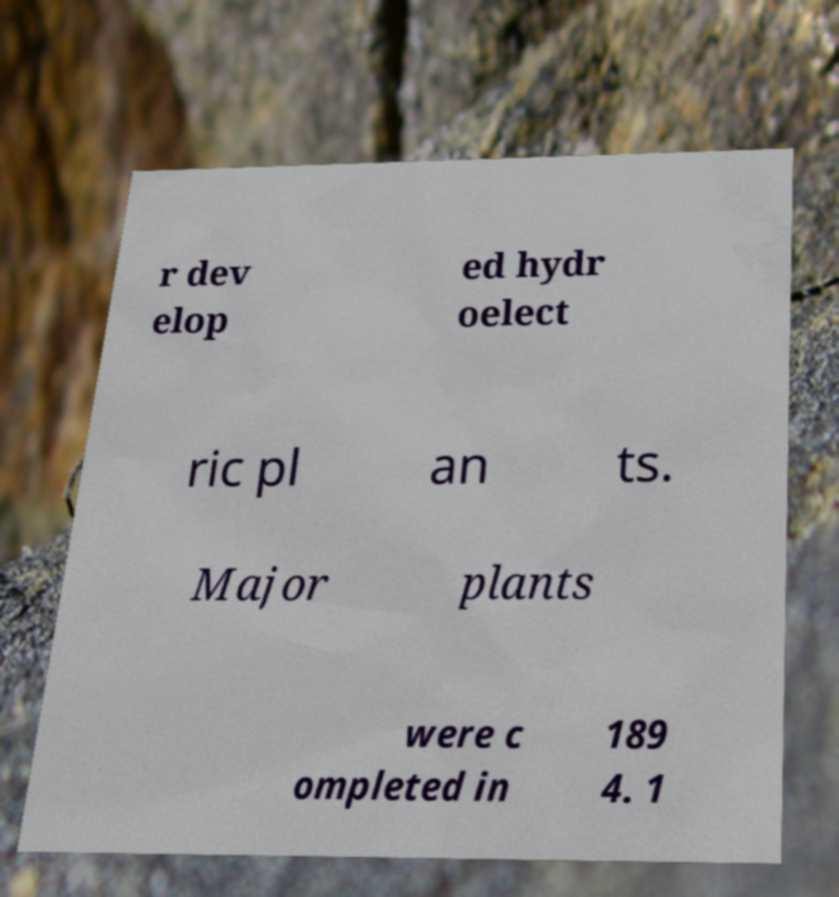Can you accurately transcribe the text from the provided image for me? r dev elop ed hydr oelect ric pl an ts. Major plants were c ompleted in 189 4. 1 